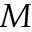<formula> <loc_0><loc_0><loc_500><loc_500>M</formula> 